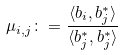Convert formula to latex. <formula><loc_0><loc_0><loc_500><loc_500>\mu _ { i , j } \colon = \frac { \langle b _ { i } , b _ { j } ^ { * } \rangle } { \langle b _ { j } ^ { * } , b _ { j } ^ { * } \rangle }</formula> 